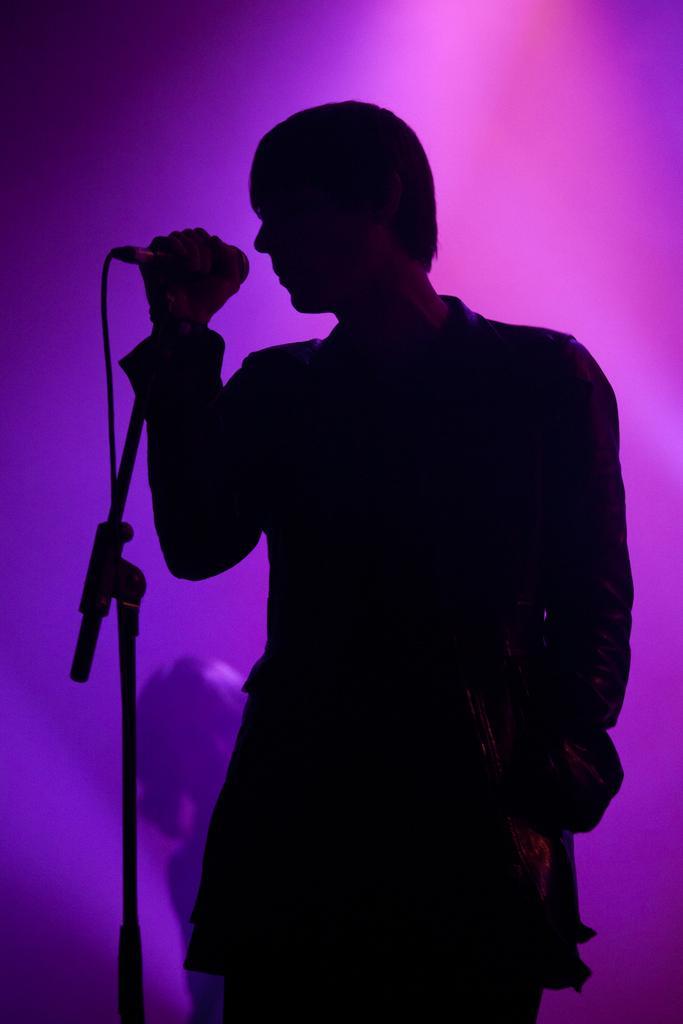In one or two sentences, can you explain what this image depicts? This image consists of a man singing in a mic. The background is in pink color. 